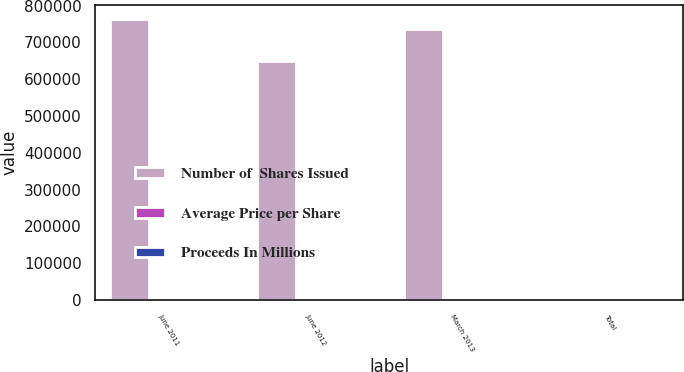Convert chart. <chart><loc_0><loc_0><loc_500><loc_500><stacked_bar_chart><ecel><fcel>June 2011<fcel>June 2012<fcel>March 2013<fcel>Total<nl><fcel>Number of  Shares Issued<fcel>762925<fcel>650235<fcel>735873<fcel>23.27<nl><fcel>Average Price per Share<fcel>19.66<fcel>23.07<fcel>27.18<fcel>23.27<nl><fcel>Proceeds In Millions<fcel>15<fcel>15<fcel>20<fcel>50<nl></chart> 